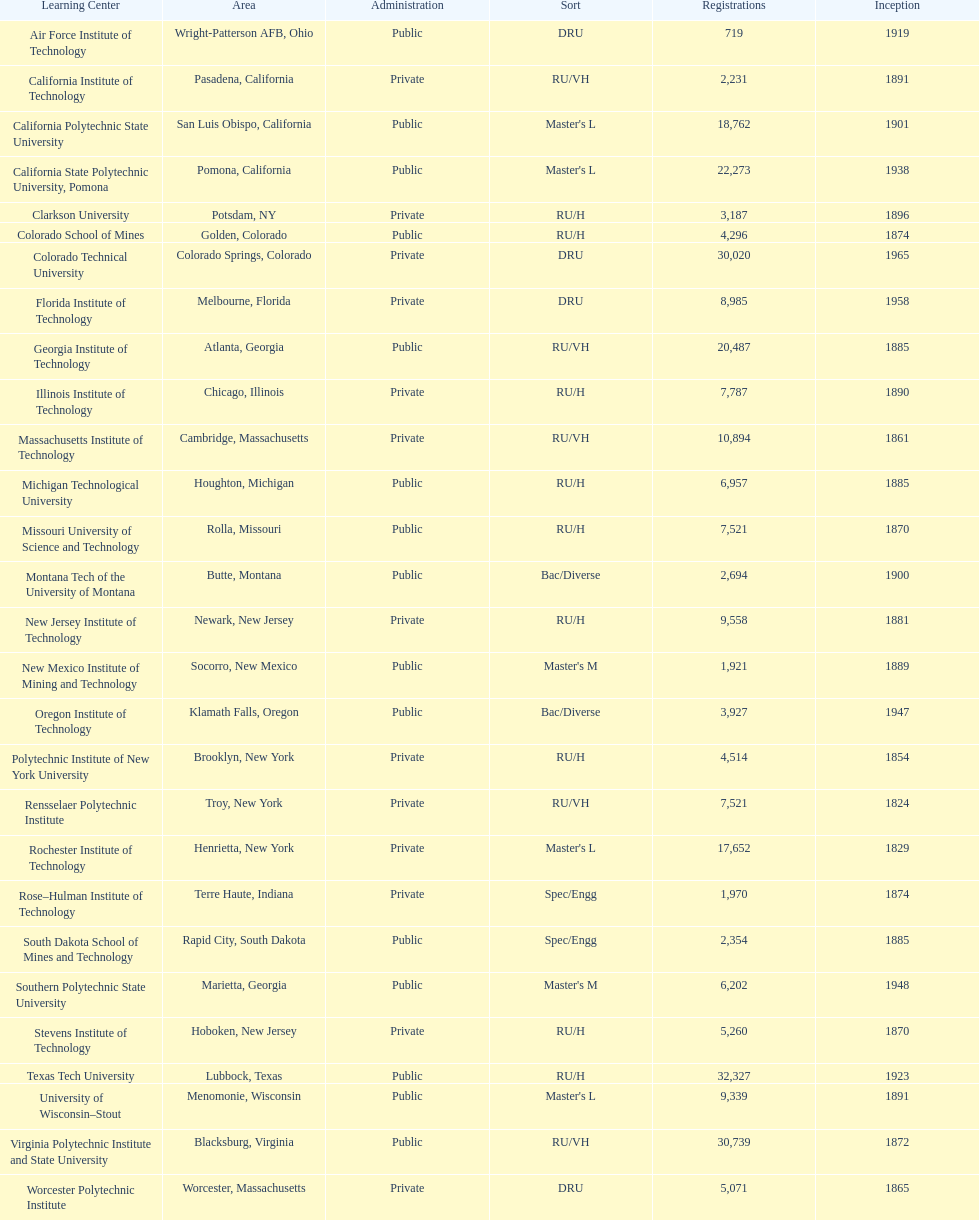Which of the universities was founded first? Rensselaer Polytechnic Institute. 